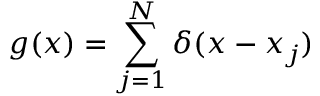Convert formula to latex. <formula><loc_0><loc_0><loc_500><loc_500>g ( x ) = \sum _ { j = 1 } ^ { N } \delta ( x - x _ { j } )</formula> 